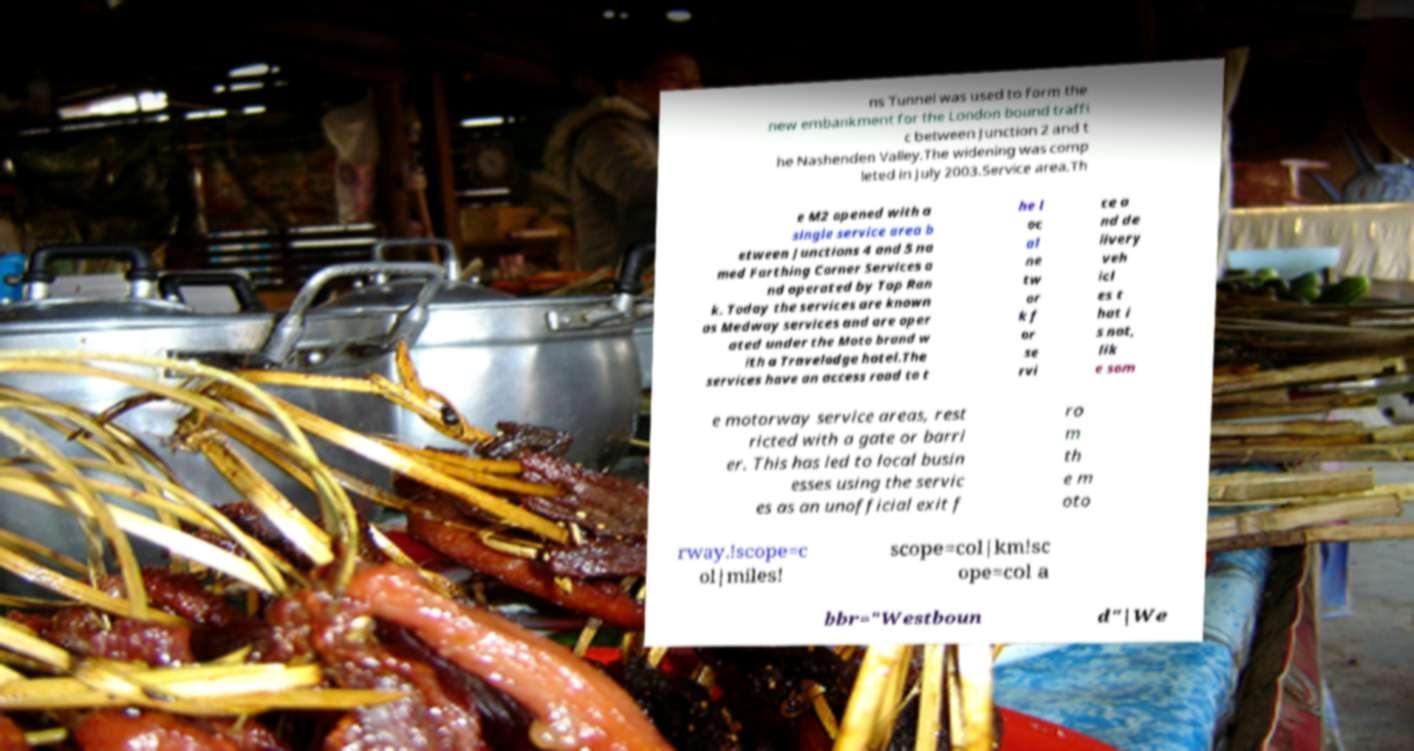Could you assist in decoding the text presented in this image and type it out clearly? ns Tunnel was used to form the new embankment for the London bound traffi c between Junction 2 and t he Nashenden Valley.The widening was comp leted in July 2003.Service area.Th e M2 opened with a single service area b etween Junctions 4 and 5 na med Farthing Corner Services a nd operated by Top Ran k. Today the services are known as Medway services and are oper ated under the Moto brand w ith a Travelodge hotel.The services have an access road to t he l oc al ne tw or k f or se rvi ce a nd de livery veh icl es t hat i s not, lik e som e motorway service areas, rest ricted with a gate or barri er. This has led to local busin esses using the servic es as an unofficial exit f ro m th e m oto rway.!scope=c ol|miles! scope=col|km!sc ope=col a bbr="Westboun d"|We 